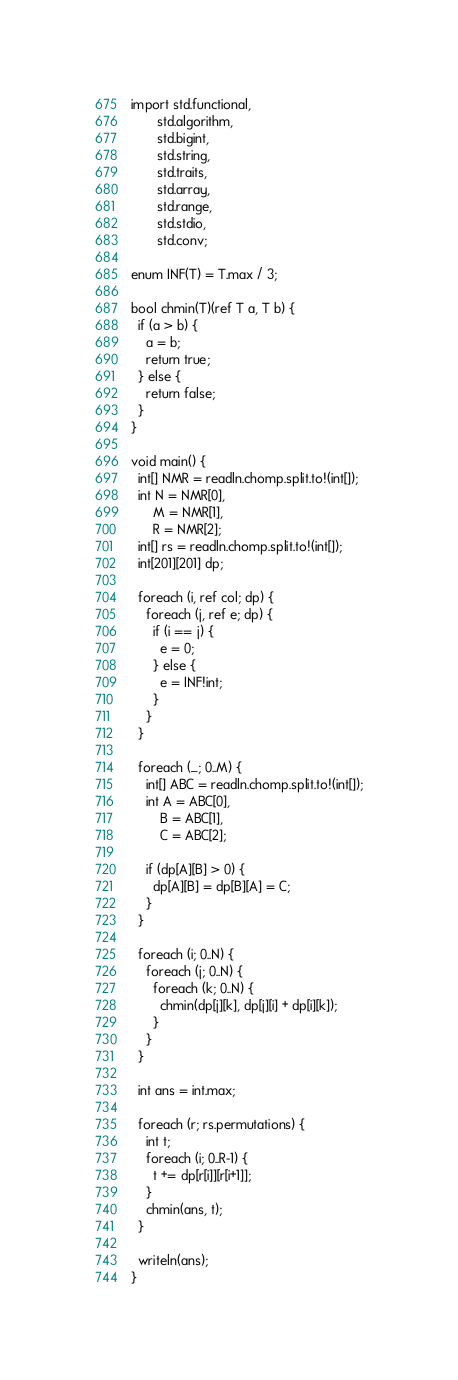<code> <loc_0><loc_0><loc_500><loc_500><_D_>import std.functional,
       std.algorithm,
       std.bigint,
       std.string,
       std.traits,
       std.array,
       std.range,
       std.stdio,
       std.conv;

enum INF(T) = T.max / 3;

bool chmin(T)(ref T a, T b) {
  if (a > b) {
    a = b;
    return true;
  } else {
    return false;
  }
}

void main() {
  int[] NMR = readln.chomp.split.to!(int[]);
  int N = NMR[0],
      M = NMR[1],
      R = NMR[2];
  int[] rs = readln.chomp.split.to!(int[]);
  int[201][201] dp;

  foreach (i, ref col; dp) {
    foreach (j, ref e; dp) {
      if (i == j) {
        e = 0;
      } else {
        e = INF!int;
      }
    }
  }

  foreach (_; 0..M) {
    int[] ABC = readln.chomp.split.to!(int[]);
    int A = ABC[0],
        B = ABC[1],
        C = ABC[2];

    if (dp[A][B] > 0) {
      dp[A][B] = dp[B][A] = C;
    }
  }

  foreach (i; 0..N) {
    foreach (j; 0..N) {
      foreach (k; 0..N) {
        chmin(dp[j][k], dp[j][i] + dp[i][k]);
      }
    }
  }

  int ans = int.max;

  foreach (r; rs.permutations) {
    int t;
    foreach (i; 0..R-1) {
      t += dp[r[i]][r[i+1]];
    }
    chmin(ans, t);
  }

  writeln(ans);
}
</code> 